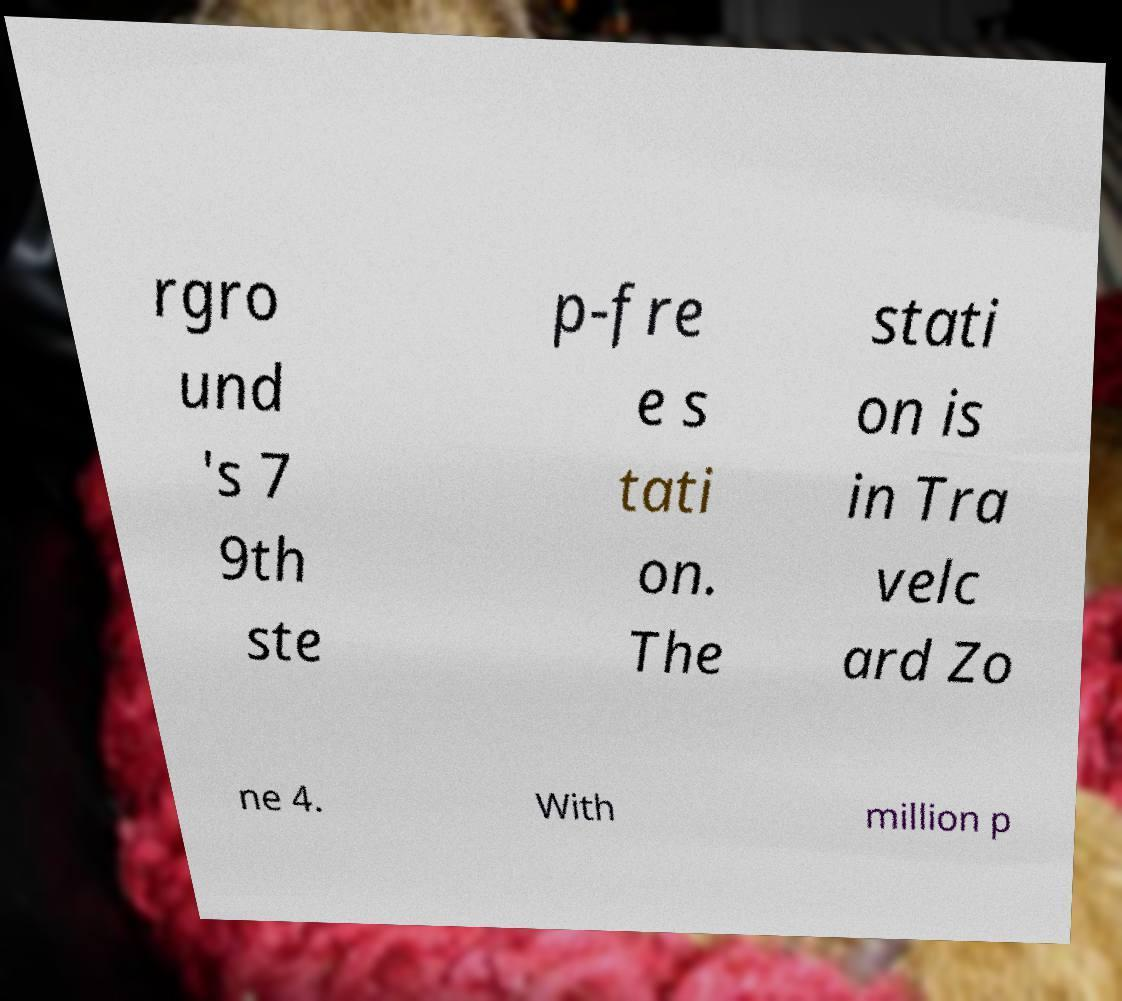What messages or text are displayed in this image? I need them in a readable, typed format. rgro und 's 7 9th ste p-fre e s tati on. The stati on is in Tra velc ard Zo ne 4. With million p 